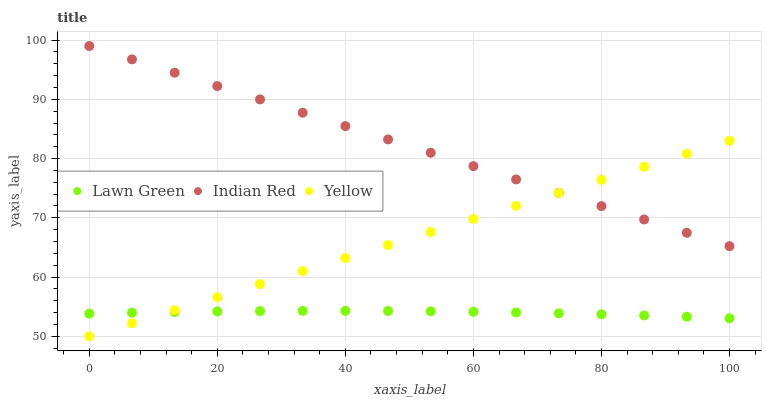Does Lawn Green have the minimum area under the curve?
Answer yes or no. Yes. Does Indian Red have the maximum area under the curve?
Answer yes or no. Yes. Does Yellow have the minimum area under the curve?
Answer yes or no. No. Does Yellow have the maximum area under the curve?
Answer yes or no. No. Is Yellow the smoothest?
Answer yes or no. Yes. Is Lawn Green the roughest?
Answer yes or no. Yes. Is Indian Red the smoothest?
Answer yes or no. No. Is Indian Red the roughest?
Answer yes or no. No. Does Yellow have the lowest value?
Answer yes or no. Yes. Does Indian Red have the lowest value?
Answer yes or no. No. Does Indian Red have the highest value?
Answer yes or no. Yes. Does Yellow have the highest value?
Answer yes or no. No. Is Lawn Green less than Indian Red?
Answer yes or no. Yes. Is Indian Red greater than Lawn Green?
Answer yes or no. Yes. Does Yellow intersect Lawn Green?
Answer yes or no. Yes. Is Yellow less than Lawn Green?
Answer yes or no. No. Is Yellow greater than Lawn Green?
Answer yes or no. No. Does Lawn Green intersect Indian Red?
Answer yes or no. No. 